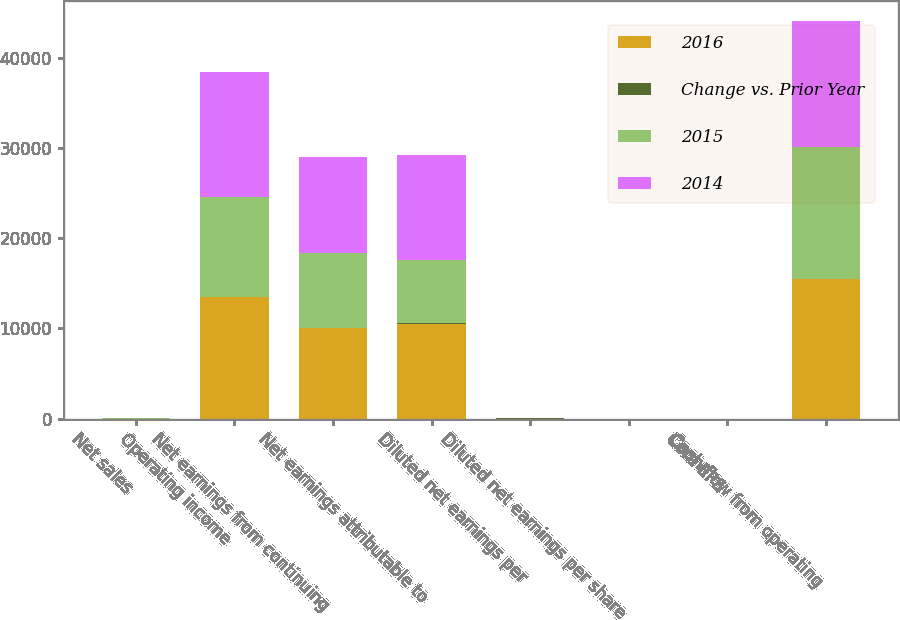Convert chart to OTSL. <chart><loc_0><loc_0><loc_500><loc_500><stacked_bar_chart><ecel><fcel>Net sales<fcel>Operating income<fcel>Net earnings from continuing<fcel>Net earnings attributable to<fcel>Diluted net earnings per<fcel>Diluted net earnings per share<fcel>Core EPS<fcel>Cash flow from operating<nl><fcel>2016<fcel>23<fcel>13441<fcel>10027<fcel>10508<fcel>3.69<fcel>3.49<fcel>3.67<fcel>15435<nl><fcel>Change vs. Prior Year<fcel>8<fcel>22<fcel>21<fcel>49<fcel>51<fcel>23<fcel>2<fcel>6<nl><fcel>2015<fcel>23<fcel>11049<fcel>8287<fcel>7036<fcel>2.44<fcel>2.84<fcel>3.76<fcel>14608<nl><fcel>2014<fcel>23<fcel>13910<fcel>10658<fcel>11643<fcel>4.01<fcel>3.63<fcel>3.85<fcel>13958<nl></chart> 